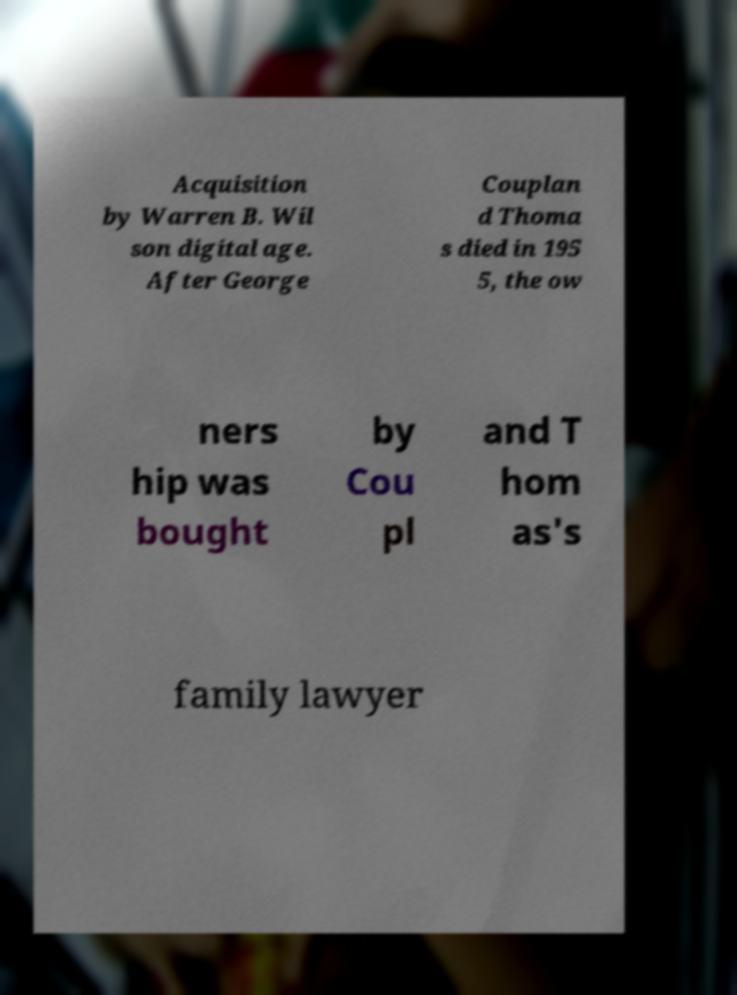Please identify and transcribe the text found in this image. Acquisition by Warren B. Wil son digital age. After George Couplan d Thoma s died in 195 5, the ow ners hip was bought by Cou pl and T hom as's family lawyer 